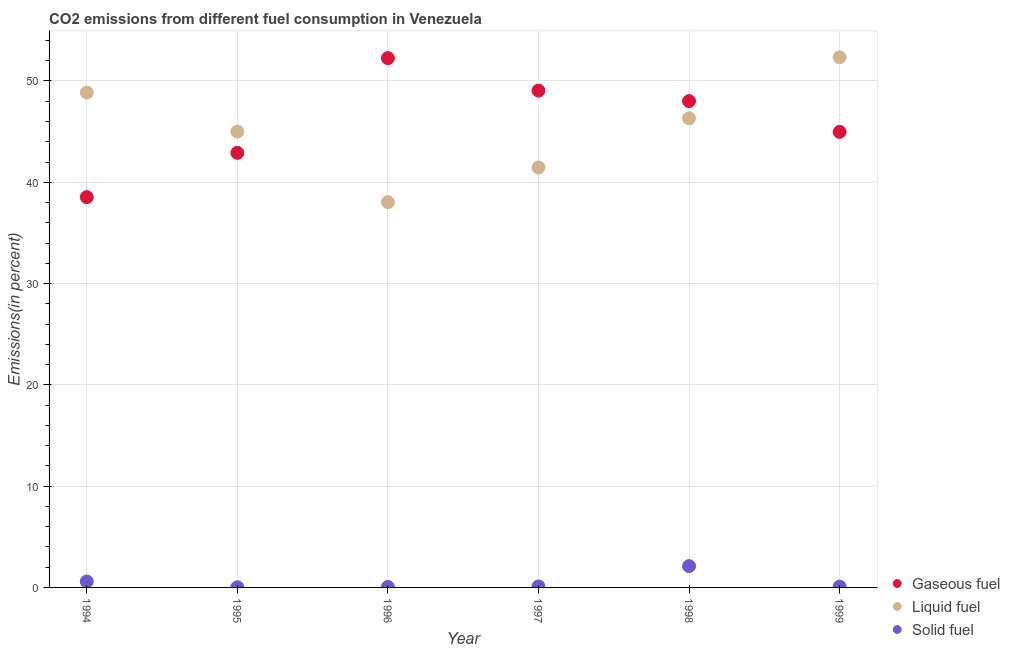How many different coloured dotlines are there?
Give a very brief answer. 3. What is the percentage of solid fuel emission in 1996?
Your answer should be compact. 0.05. Across all years, what is the maximum percentage of solid fuel emission?
Provide a short and direct response. 2.1. Across all years, what is the minimum percentage of solid fuel emission?
Offer a terse response. 0.01. In which year was the percentage of liquid fuel emission maximum?
Provide a short and direct response. 1999. In which year was the percentage of gaseous fuel emission minimum?
Your answer should be compact. 1994. What is the total percentage of liquid fuel emission in the graph?
Your answer should be very brief. 272.01. What is the difference between the percentage of solid fuel emission in 1994 and that in 1996?
Offer a terse response. 0.54. What is the difference between the percentage of solid fuel emission in 1997 and the percentage of liquid fuel emission in 1999?
Make the answer very short. -52.24. What is the average percentage of gaseous fuel emission per year?
Your response must be concise. 45.96. In the year 1994, what is the difference between the percentage of liquid fuel emission and percentage of gaseous fuel emission?
Provide a succinct answer. 10.32. What is the ratio of the percentage of solid fuel emission in 1994 to that in 1995?
Ensure brevity in your answer.  42.68. Is the percentage of solid fuel emission in 1994 less than that in 1996?
Your response must be concise. No. What is the difference between the highest and the second highest percentage of solid fuel emission?
Make the answer very short. 1.52. What is the difference between the highest and the lowest percentage of solid fuel emission?
Ensure brevity in your answer.  2.09. In how many years, is the percentage of liquid fuel emission greater than the average percentage of liquid fuel emission taken over all years?
Ensure brevity in your answer.  3. Is the sum of the percentage of liquid fuel emission in 1997 and 1998 greater than the maximum percentage of solid fuel emission across all years?
Your answer should be very brief. Yes. Is the percentage of liquid fuel emission strictly greater than the percentage of gaseous fuel emission over the years?
Give a very brief answer. No. Is the percentage of liquid fuel emission strictly less than the percentage of gaseous fuel emission over the years?
Your answer should be very brief. No. How many years are there in the graph?
Your response must be concise. 6. What is the difference between two consecutive major ticks on the Y-axis?
Provide a succinct answer. 10. Does the graph contain any zero values?
Make the answer very short. No. How many legend labels are there?
Your answer should be very brief. 3. What is the title of the graph?
Provide a succinct answer. CO2 emissions from different fuel consumption in Venezuela. Does "Total employers" appear as one of the legend labels in the graph?
Your response must be concise. No. What is the label or title of the X-axis?
Your response must be concise. Year. What is the label or title of the Y-axis?
Keep it short and to the point. Emissions(in percent). What is the Emissions(in percent) in Gaseous fuel in 1994?
Keep it short and to the point. 38.53. What is the Emissions(in percent) in Liquid fuel in 1994?
Make the answer very short. 48.85. What is the Emissions(in percent) of Solid fuel in 1994?
Provide a succinct answer. 0.59. What is the Emissions(in percent) of Gaseous fuel in 1995?
Ensure brevity in your answer.  42.9. What is the Emissions(in percent) of Liquid fuel in 1995?
Offer a terse response. 45. What is the Emissions(in percent) of Solid fuel in 1995?
Provide a succinct answer. 0.01. What is the Emissions(in percent) of Gaseous fuel in 1996?
Give a very brief answer. 52.26. What is the Emissions(in percent) in Liquid fuel in 1996?
Keep it short and to the point. 38.04. What is the Emissions(in percent) in Solid fuel in 1996?
Ensure brevity in your answer.  0.05. What is the Emissions(in percent) of Gaseous fuel in 1997?
Give a very brief answer. 49.05. What is the Emissions(in percent) of Liquid fuel in 1997?
Make the answer very short. 41.46. What is the Emissions(in percent) in Solid fuel in 1997?
Ensure brevity in your answer.  0.09. What is the Emissions(in percent) of Gaseous fuel in 1998?
Offer a terse response. 48.01. What is the Emissions(in percent) of Liquid fuel in 1998?
Offer a very short reply. 46.32. What is the Emissions(in percent) of Solid fuel in 1998?
Your answer should be very brief. 2.1. What is the Emissions(in percent) in Gaseous fuel in 1999?
Your answer should be compact. 44.97. What is the Emissions(in percent) in Liquid fuel in 1999?
Keep it short and to the point. 52.34. What is the Emissions(in percent) of Solid fuel in 1999?
Your response must be concise. 0.08. Across all years, what is the maximum Emissions(in percent) of Gaseous fuel?
Your answer should be compact. 52.26. Across all years, what is the maximum Emissions(in percent) of Liquid fuel?
Provide a succinct answer. 52.34. Across all years, what is the maximum Emissions(in percent) of Solid fuel?
Offer a very short reply. 2.1. Across all years, what is the minimum Emissions(in percent) in Gaseous fuel?
Ensure brevity in your answer.  38.53. Across all years, what is the minimum Emissions(in percent) of Liquid fuel?
Ensure brevity in your answer.  38.04. Across all years, what is the minimum Emissions(in percent) in Solid fuel?
Offer a terse response. 0.01. What is the total Emissions(in percent) in Gaseous fuel in the graph?
Your response must be concise. 275.73. What is the total Emissions(in percent) of Liquid fuel in the graph?
Provide a succinct answer. 272.01. What is the total Emissions(in percent) of Solid fuel in the graph?
Keep it short and to the point. 2.92. What is the difference between the Emissions(in percent) in Gaseous fuel in 1994 and that in 1995?
Offer a very short reply. -4.37. What is the difference between the Emissions(in percent) of Liquid fuel in 1994 and that in 1995?
Your response must be concise. 3.85. What is the difference between the Emissions(in percent) of Solid fuel in 1994 and that in 1995?
Your answer should be very brief. 0.57. What is the difference between the Emissions(in percent) in Gaseous fuel in 1994 and that in 1996?
Keep it short and to the point. -13.72. What is the difference between the Emissions(in percent) in Liquid fuel in 1994 and that in 1996?
Give a very brief answer. 10.81. What is the difference between the Emissions(in percent) of Solid fuel in 1994 and that in 1996?
Offer a terse response. 0.54. What is the difference between the Emissions(in percent) in Gaseous fuel in 1994 and that in 1997?
Provide a short and direct response. -10.52. What is the difference between the Emissions(in percent) of Liquid fuel in 1994 and that in 1997?
Ensure brevity in your answer.  7.4. What is the difference between the Emissions(in percent) in Solid fuel in 1994 and that in 1997?
Provide a succinct answer. 0.49. What is the difference between the Emissions(in percent) in Gaseous fuel in 1994 and that in 1998?
Offer a very short reply. -9.48. What is the difference between the Emissions(in percent) in Liquid fuel in 1994 and that in 1998?
Your answer should be compact. 2.54. What is the difference between the Emissions(in percent) of Solid fuel in 1994 and that in 1998?
Your response must be concise. -1.52. What is the difference between the Emissions(in percent) of Gaseous fuel in 1994 and that in 1999?
Your response must be concise. -6.44. What is the difference between the Emissions(in percent) of Liquid fuel in 1994 and that in 1999?
Your answer should be very brief. -3.48. What is the difference between the Emissions(in percent) of Solid fuel in 1994 and that in 1999?
Ensure brevity in your answer.  0.51. What is the difference between the Emissions(in percent) in Gaseous fuel in 1995 and that in 1996?
Make the answer very short. -9.35. What is the difference between the Emissions(in percent) of Liquid fuel in 1995 and that in 1996?
Your answer should be compact. 6.96. What is the difference between the Emissions(in percent) in Solid fuel in 1995 and that in 1996?
Provide a short and direct response. -0.03. What is the difference between the Emissions(in percent) in Gaseous fuel in 1995 and that in 1997?
Your answer should be very brief. -6.15. What is the difference between the Emissions(in percent) of Liquid fuel in 1995 and that in 1997?
Your response must be concise. 3.55. What is the difference between the Emissions(in percent) in Solid fuel in 1995 and that in 1997?
Ensure brevity in your answer.  -0.08. What is the difference between the Emissions(in percent) of Gaseous fuel in 1995 and that in 1998?
Keep it short and to the point. -5.11. What is the difference between the Emissions(in percent) in Liquid fuel in 1995 and that in 1998?
Ensure brevity in your answer.  -1.31. What is the difference between the Emissions(in percent) in Solid fuel in 1995 and that in 1998?
Your response must be concise. -2.09. What is the difference between the Emissions(in percent) in Gaseous fuel in 1995 and that in 1999?
Provide a short and direct response. -2.07. What is the difference between the Emissions(in percent) in Liquid fuel in 1995 and that in 1999?
Your answer should be compact. -7.33. What is the difference between the Emissions(in percent) of Solid fuel in 1995 and that in 1999?
Provide a succinct answer. -0.06. What is the difference between the Emissions(in percent) in Gaseous fuel in 1996 and that in 1997?
Provide a short and direct response. 3.21. What is the difference between the Emissions(in percent) in Liquid fuel in 1996 and that in 1997?
Your response must be concise. -3.41. What is the difference between the Emissions(in percent) in Solid fuel in 1996 and that in 1997?
Your response must be concise. -0.05. What is the difference between the Emissions(in percent) in Gaseous fuel in 1996 and that in 1998?
Your response must be concise. 4.24. What is the difference between the Emissions(in percent) in Liquid fuel in 1996 and that in 1998?
Make the answer very short. -8.27. What is the difference between the Emissions(in percent) of Solid fuel in 1996 and that in 1998?
Your response must be concise. -2.06. What is the difference between the Emissions(in percent) in Gaseous fuel in 1996 and that in 1999?
Your response must be concise. 7.28. What is the difference between the Emissions(in percent) in Liquid fuel in 1996 and that in 1999?
Your answer should be compact. -14.29. What is the difference between the Emissions(in percent) in Solid fuel in 1996 and that in 1999?
Your response must be concise. -0.03. What is the difference between the Emissions(in percent) of Gaseous fuel in 1997 and that in 1998?
Give a very brief answer. 1.04. What is the difference between the Emissions(in percent) in Liquid fuel in 1997 and that in 1998?
Offer a terse response. -4.86. What is the difference between the Emissions(in percent) in Solid fuel in 1997 and that in 1998?
Offer a very short reply. -2.01. What is the difference between the Emissions(in percent) in Gaseous fuel in 1997 and that in 1999?
Keep it short and to the point. 4.07. What is the difference between the Emissions(in percent) of Liquid fuel in 1997 and that in 1999?
Give a very brief answer. -10.88. What is the difference between the Emissions(in percent) of Solid fuel in 1997 and that in 1999?
Give a very brief answer. 0.02. What is the difference between the Emissions(in percent) in Gaseous fuel in 1998 and that in 1999?
Give a very brief answer. 3.04. What is the difference between the Emissions(in percent) of Liquid fuel in 1998 and that in 1999?
Offer a terse response. -6.02. What is the difference between the Emissions(in percent) in Solid fuel in 1998 and that in 1999?
Offer a terse response. 2.03. What is the difference between the Emissions(in percent) of Gaseous fuel in 1994 and the Emissions(in percent) of Liquid fuel in 1995?
Offer a very short reply. -6.47. What is the difference between the Emissions(in percent) in Gaseous fuel in 1994 and the Emissions(in percent) in Solid fuel in 1995?
Your response must be concise. 38.52. What is the difference between the Emissions(in percent) in Liquid fuel in 1994 and the Emissions(in percent) in Solid fuel in 1995?
Make the answer very short. 48.84. What is the difference between the Emissions(in percent) in Gaseous fuel in 1994 and the Emissions(in percent) in Liquid fuel in 1996?
Your answer should be compact. 0.49. What is the difference between the Emissions(in percent) in Gaseous fuel in 1994 and the Emissions(in percent) in Solid fuel in 1996?
Offer a very short reply. 38.49. What is the difference between the Emissions(in percent) in Liquid fuel in 1994 and the Emissions(in percent) in Solid fuel in 1996?
Your answer should be very brief. 48.81. What is the difference between the Emissions(in percent) of Gaseous fuel in 1994 and the Emissions(in percent) of Liquid fuel in 1997?
Provide a short and direct response. -2.92. What is the difference between the Emissions(in percent) of Gaseous fuel in 1994 and the Emissions(in percent) of Solid fuel in 1997?
Provide a short and direct response. 38.44. What is the difference between the Emissions(in percent) of Liquid fuel in 1994 and the Emissions(in percent) of Solid fuel in 1997?
Your answer should be very brief. 48.76. What is the difference between the Emissions(in percent) of Gaseous fuel in 1994 and the Emissions(in percent) of Liquid fuel in 1998?
Provide a short and direct response. -7.78. What is the difference between the Emissions(in percent) of Gaseous fuel in 1994 and the Emissions(in percent) of Solid fuel in 1998?
Offer a terse response. 36.43. What is the difference between the Emissions(in percent) in Liquid fuel in 1994 and the Emissions(in percent) in Solid fuel in 1998?
Provide a short and direct response. 46.75. What is the difference between the Emissions(in percent) of Gaseous fuel in 1994 and the Emissions(in percent) of Liquid fuel in 1999?
Provide a succinct answer. -13.8. What is the difference between the Emissions(in percent) in Gaseous fuel in 1994 and the Emissions(in percent) in Solid fuel in 1999?
Give a very brief answer. 38.46. What is the difference between the Emissions(in percent) in Liquid fuel in 1994 and the Emissions(in percent) in Solid fuel in 1999?
Offer a very short reply. 48.78. What is the difference between the Emissions(in percent) of Gaseous fuel in 1995 and the Emissions(in percent) of Liquid fuel in 1996?
Ensure brevity in your answer.  4.86. What is the difference between the Emissions(in percent) in Gaseous fuel in 1995 and the Emissions(in percent) in Solid fuel in 1996?
Give a very brief answer. 42.86. What is the difference between the Emissions(in percent) of Liquid fuel in 1995 and the Emissions(in percent) of Solid fuel in 1996?
Provide a short and direct response. 44.96. What is the difference between the Emissions(in percent) in Gaseous fuel in 1995 and the Emissions(in percent) in Liquid fuel in 1997?
Your answer should be very brief. 1.45. What is the difference between the Emissions(in percent) in Gaseous fuel in 1995 and the Emissions(in percent) in Solid fuel in 1997?
Keep it short and to the point. 42.81. What is the difference between the Emissions(in percent) of Liquid fuel in 1995 and the Emissions(in percent) of Solid fuel in 1997?
Your answer should be compact. 44.91. What is the difference between the Emissions(in percent) of Gaseous fuel in 1995 and the Emissions(in percent) of Liquid fuel in 1998?
Ensure brevity in your answer.  -3.41. What is the difference between the Emissions(in percent) of Gaseous fuel in 1995 and the Emissions(in percent) of Solid fuel in 1998?
Your answer should be compact. 40.8. What is the difference between the Emissions(in percent) in Liquid fuel in 1995 and the Emissions(in percent) in Solid fuel in 1998?
Provide a short and direct response. 42.9. What is the difference between the Emissions(in percent) of Gaseous fuel in 1995 and the Emissions(in percent) of Liquid fuel in 1999?
Keep it short and to the point. -9.43. What is the difference between the Emissions(in percent) in Gaseous fuel in 1995 and the Emissions(in percent) in Solid fuel in 1999?
Keep it short and to the point. 42.83. What is the difference between the Emissions(in percent) of Liquid fuel in 1995 and the Emissions(in percent) of Solid fuel in 1999?
Provide a short and direct response. 44.93. What is the difference between the Emissions(in percent) in Gaseous fuel in 1996 and the Emissions(in percent) in Liquid fuel in 1997?
Your answer should be compact. 10.8. What is the difference between the Emissions(in percent) of Gaseous fuel in 1996 and the Emissions(in percent) of Solid fuel in 1997?
Provide a short and direct response. 52.16. What is the difference between the Emissions(in percent) of Liquid fuel in 1996 and the Emissions(in percent) of Solid fuel in 1997?
Keep it short and to the point. 37.95. What is the difference between the Emissions(in percent) in Gaseous fuel in 1996 and the Emissions(in percent) in Liquid fuel in 1998?
Give a very brief answer. 5.94. What is the difference between the Emissions(in percent) of Gaseous fuel in 1996 and the Emissions(in percent) of Solid fuel in 1998?
Ensure brevity in your answer.  50.15. What is the difference between the Emissions(in percent) in Liquid fuel in 1996 and the Emissions(in percent) in Solid fuel in 1998?
Your response must be concise. 35.94. What is the difference between the Emissions(in percent) of Gaseous fuel in 1996 and the Emissions(in percent) of Liquid fuel in 1999?
Offer a terse response. -0.08. What is the difference between the Emissions(in percent) in Gaseous fuel in 1996 and the Emissions(in percent) in Solid fuel in 1999?
Offer a very short reply. 52.18. What is the difference between the Emissions(in percent) of Liquid fuel in 1996 and the Emissions(in percent) of Solid fuel in 1999?
Your answer should be compact. 37.97. What is the difference between the Emissions(in percent) in Gaseous fuel in 1997 and the Emissions(in percent) in Liquid fuel in 1998?
Your answer should be compact. 2.73. What is the difference between the Emissions(in percent) in Gaseous fuel in 1997 and the Emissions(in percent) in Solid fuel in 1998?
Provide a short and direct response. 46.95. What is the difference between the Emissions(in percent) of Liquid fuel in 1997 and the Emissions(in percent) of Solid fuel in 1998?
Your answer should be very brief. 39.35. What is the difference between the Emissions(in percent) of Gaseous fuel in 1997 and the Emissions(in percent) of Liquid fuel in 1999?
Your answer should be compact. -3.29. What is the difference between the Emissions(in percent) in Gaseous fuel in 1997 and the Emissions(in percent) in Solid fuel in 1999?
Ensure brevity in your answer.  48.97. What is the difference between the Emissions(in percent) of Liquid fuel in 1997 and the Emissions(in percent) of Solid fuel in 1999?
Offer a very short reply. 41.38. What is the difference between the Emissions(in percent) in Gaseous fuel in 1998 and the Emissions(in percent) in Liquid fuel in 1999?
Provide a short and direct response. -4.32. What is the difference between the Emissions(in percent) of Gaseous fuel in 1998 and the Emissions(in percent) of Solid fuel in 1999?
Your response must be concise. 47.94. What is the difference between the Emissions(in percent) in Liquid fuel in 1998 and the Emissions(in percent) in Solid fuel in 1999?
Your answer should be very brief. 46.24. What is the average Emissions(in percent) in Gaseous fuel per year?
Offer a very short reply. 45.96. What is the average Emissions(in percent) of Liquid fuel per year?
Offer a terse response. 45.33. What is the average Emissions(in percent) in Solid fuel per year?
Offer a terse response. 0.49. In the year 1994, what is the difference between the Emissions(in percent) of Gaseous fuel and Emissions(in percent) of Liquid fuel?
Keep it short and to the point. -10.32. In the year 1994, what is the difference between the Emissions(in percent) of Gaseous fuel and Emissions(in percent) of Solid fuel?
Give a very brief answer. 37.95. In the year 1994, what is the difference between the Emissions(in percent) in Liquid fuel and Emissions(in percent) in Solid fuel?
Offer a very short reply. 48.27. In the year 1995, what is the difference between the Emissions(in percent) of Gaseous fuel and Emissions(in percent) of Liquid fuel?
Your answer should be compact. -2.1. In the year 1995, what is the difference between the Emissions(in percent) of Gaseous fuel and Emissions(in percent) of Solid fuel?
Make the answer very short. 42.89. In the year 1995, what is the difference between the Emissions(in percent) of Liquid fuel and Emissions(in percent) of Solid fuel?
Make the answer very short. 44.99. In the year 1996, what is the difference between the Emissions(in percent) in Gaseous fuel and Emissions(in percent) in Liquid fuel?
Provide a succinct answer. 14.21. In the year 1996, what is the difference between the Emissions(in percent) of Gaseous fuel and Emissions(in percent) of Solid fuel?
Give a very brief answer. 52.21. In the year 1996, what is the difference between the Emissions(in percent) of Liquid fuel and Emissions(in percent) of Solid fuel?
Offer a very short reply. 37.99. In the year 1997, what is the difference between the Emissions(in percent) of Gaseous fuel and Emissions(in percent) of Liquid fuel?
Make the answer very short. 7.59. In the year 1997, what is the difference between the Emissions(in percent) in Gaseous fuel and Emissions(in percent) in Solid fuel?
Keep it short and to the point. 48.96. In the year 1997, what is the difference between the Emissions(in percent) of Liquid fuel and Emissions(in percent) of Solid fuel?
Make the answer very short. 41.36. In the year 1998, what is the difference between the Emissions(in percent) of Gaseous fuel and Emissions(in percent) of Liquid fuel?
Ensure brevity in your answer.  1.7. In the year 1998, what is the difference between the Emissions(in percent) of Gaseous fuel and Emissions(in percent) of Solid fuel?
Offer a very short reply. 45.91. In the year 1998, what is the difference between the Emissions(in percent) of Liquid fuel and Emissions(in percent) of Solid fuel?
Your response must be concise. 44.21. In the year 1999, what is the difference between the Emissions(in percent) of Gaseous fuel and Emissions(in percent) of Liquid fuel?
Provide a short and direct response. -7.36. In the year 1999, what is the difference between the Emissions(in percent) in Gaseous fuel and Emissions(in percent) in Solid fuel?
Your answer should be very brief. 44.9. In the year 1999, what is the difference between the Emissions(in percent) of Liquid fuel and Emissions(in percent) of Solid fuel?
Give a very brief answer. 52.26. What is the ratio of the Emissions(in percent) in Gaseous fuel in 1994 to that in 1995?
Your answer should be very brief. 0.9. What is the ratio of the Emissions(in percent) in Liquid fuel in 1994 to that in 1995?
Provide a short and direct response. 1.09. What is the ratio of the Emissions(in percent) of Solid fuel in 1994 to that in 1995?
Give a very brief answer. 42.68. What is the ratio of the Emissions(in percent) of Gaseous fuel in 1994 to that in 1996?
Your answer should be compact. 0.74. What is the ratio of the Emissions(in percent) in Liquid fuel in 1994 to that in 1996?
Ensure brevity in your answer.  1.28. What is the ratio of the Emissions(in percent) of Solid fuel in 1994 to that in 1996?
Give a very brief answer. 12.28. What is the ratio of the Emissions(in percent) in Gaseous fuel in 1994 to that in 1997?
Give a very brief answer. 0.79. What is the ratio of the Emissions(in percent) in Liquid fuel in 1994 to that in 1997?
Your response must be concise. 1.18. What is the ratio of the Emissions(in percent) of Solid fuel in 1994 to that in 1997?
Offer a terse response. 6.31. What is the ratio of the Emissions(in percent) in Gaseous fuel in 1994 to that in 1998?
Provide a succinct answer. 0.8. What is the ratio of the Emissions(in percent) of Liquid fuel in 1994 to that in 1998?
Provide a short and direct response. 1.05. What is the ratio of the Emissions(in percent) in Solid fuel in 1994 to that in 1998?
Offer a very short reply. 0.28. What is the ratio of the Emissions(in percent) in Gaseous fuel in 1994 to that in 1999?
Provide a short and direct response. 0.86. What is the ratio of the Emissions(in percent) in Liquid fuel in 1994 to that in 1999?
Make the answer very short. 0.93. What is the ratio of the Emissions(in percent) in Solid fuel in 1994 to that in 1999?
Provide a short and direct response. 7.7. What is the ratio of the Emissions(in percent) of Gaseous fuel in 1995 to that in 1996?
Provide a short and direct response. 0.82. What is the ratio of the Emissions(in percent) of Liquid fuel in 1995 to that in 1996?
Offer a terse response. 1.18. What is the ratio of the Emissions(in percent) of Solid fuel in 1995 to that in 1996?
Offer a very short reply. 0.29. What is the ratio of the Emissions(in percent) of Gaseous fuel in 1995 to that in 1997?
Make the answer very short. 0.87. What is the ratio of the Emissions(in percent) in Liquid fuel in 1995 to that in 1997?
Offer a terse response. 1.09. What is the ratio of the Emissions(in percent) in Solid fuel in 1995 to that in 1997?
Your answer should be compact. 0.15. What is the ratio of the Emissions(in percent) of Gaseous fuel in 1995 to that in 1998?
Make the answer very short. 0.89. What is the ratio of the Emissions(in percent) of Liquid fuel in 1995 to that in 1998?
Provide a succinct answer. 0.97. What is the ratio of the Emissions(in percent) in Solid fuel in 1995 to that in 1998?
Ensure brevity in your answer.  0.01. What is the ratio of the Emissions(in percent) of Gaseous fuel in 1995 to that in 1999?
Your answer should be very brief. 0.95. What is the ratio of the Emissions(in percent) of Liquid fuel in 1995 to that in 1999?
Make the answer very short. 0.86. What is the ratio of the Emissions(in percent) in Solid fuel in 1995 to that in 1999?
Provide a short and direct response. 0.18. What is the ratio of the Emissions(in percent) in Gaseous fuel in 1996 to that in 1997?
Give a very brief answer. 1.07. What is the ratio of the Emissions(in percent) of Liquid fuel in 1996 to that in 1997?
Provide a short and direct response. 0.92. What is the ratio of the Emissions(in percent) of Solid fuel in 1996 to that in 1997?
Your response must be concise. 0.51. What is the ratio of the Emissions(in percent) of Gaseous fuel in 1996 to that in 1998?
Provide a succinct answer. 1.09. What is the ratio of the Emissions(in percent) in Liquid fuel in 1996 to that in 1998?
Your answer should be compact. 0.82. What is the ratio of the Emissions(in percent) in Solid fuel in 1996 to that in 1998?
Your answer should be compact. 0.02. What is the ratio of the Emissions(in percent) in Gaseous fuel in 1996 to that in 1999?
Offer a very short reply. 1.16. What is the ratio of the Emissions(in percent) of Liquid fuel in 1996 to that in 1999?
Ensure brevity in your answer.  0.73. What is the ratio of the Emissions(in percent) of Solid fuel in 1996 to that in 1999?
Give a very brief answer. 0.63. What is the ratio of the Emissions(in percent) of Gaseous fuel in 1997 to that in 1998?
Ensure brevity in your answer.  1.02. What is the ratio of the Emissions(in percent) in Liquid fuel in 1997 to that in 1998?
Ensure brevity in your answer.  0.9. What is the ratio of the Emissions(in percent) in Solid fuel in 1997 to that in 1998?
Provide a short and direct response. 0.04. What is the ratio of the Emissions(in percent) in Gaseous fuel in 1997 to that in 1999?
Provide a short and direct response. 1.09. What is the ratio of the Emissions(in percent) in Liquid fuel in 1997 to that in 1999?
Your answer should be compact. 0.79. What is the ratio of the Emissions(in percent) of Solid fuel in 1997 to that in 1999?
Ensure brevity in your answer.  1.22. What is the ratio of the Emissions(in percent) of Gaseous fuel in 1998 to that in 1999?
Keep it short and to the point. 1.07. What is the ratio of the Emissions(in percent) of Liquid fuel in 1998 to that in 1999?
Offer a very short reply. 0.89. What is the ratio of the Emissions(in percent) of Solid fuel in 1998 to that in 1999?
Provide a short and direct response. 27.59. What is the difference between the highest and the second highest Emissions(in percent) in Gaseous fuel?
Keep it short and to the point. 3.21. What is the difference between the highest and the second highest Emissions(in percent) of Liquid fuel?
Keep it short and to the point. 3.48. What is the difference between the highest and the second highest Emissions(in percent) of Solid fuel?
Your answer should be very brief. 1.52. What is the difference between the highest and the lowest Emissions(in percent) of Gaseous fuel?
Ensure brevity in your answer.  13.72. What is the difference between the highest and the lowest Emissions(in percent) of Liquid fuel?
Provide a succinct answer. 14.29. What is the difference between the highest and the lowest Emissions(in percent) of Solid fuel?
Provide a short and direct response. 2.09. 